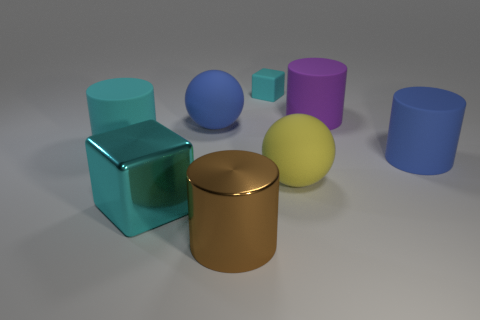Do the small cyan thing and the large blue object to the right of the brown metallic cylinder have the same shape?
Keep it short and to the point. No. What number of objects are either large blue rubber things that are to the left of the yellow matte ball or big blue matte objects?
Keep it short and to the point. 2. Is the material of the yellow object the same as the ball left of the matte cube?
Offer a very short reply. Yes. The blue thing left of the cube right of the brown cylinder is what shape?
Provide a succinct answer. Sphere. There is a small block; does it have the same color as the big rubber object that is behind the large blue matte sphere?
Ensure brevity in your answer.  No. Is there any other thing that has the same material as the tiny thing?
Your response must be concise. Yes. What shape is the tiny cyan matte object?
Offer a very short reply. Cube. What size is the sphere that is behind the cyan rubber object on the left side of the blue ball?
Give a very brief answer. Large. Are there the same number of cubes behind the tiny matte cube and large purple rubber cylinders on the right side of the large metallic cylinder?
Your response must be concise. No. What material is the cylinder that is behind the large blue rubber cylinder and left of the small cyan rubber block?
Ensure brevity in your answer.  Rubber. 